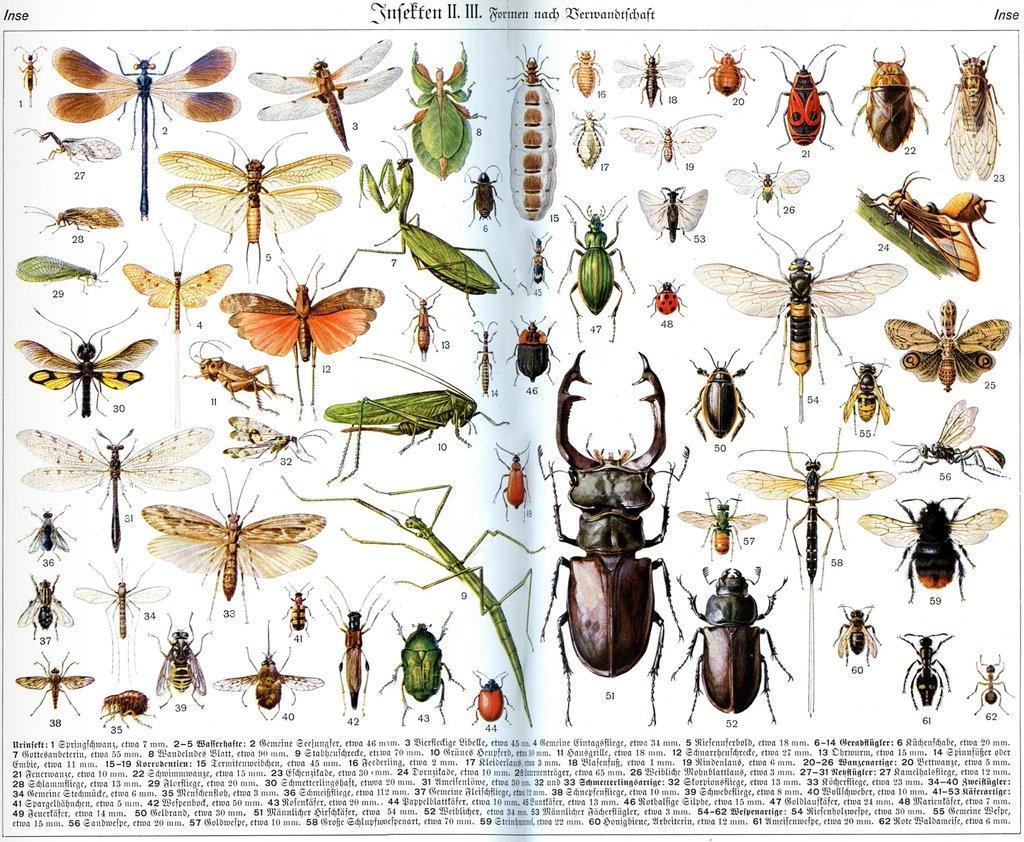Can you describe this image briefly? This image consists of a poster. On this poster, I can see a dragonfly, fly, an ant and many other insects. At the bottom of this poster, I can see some text. 